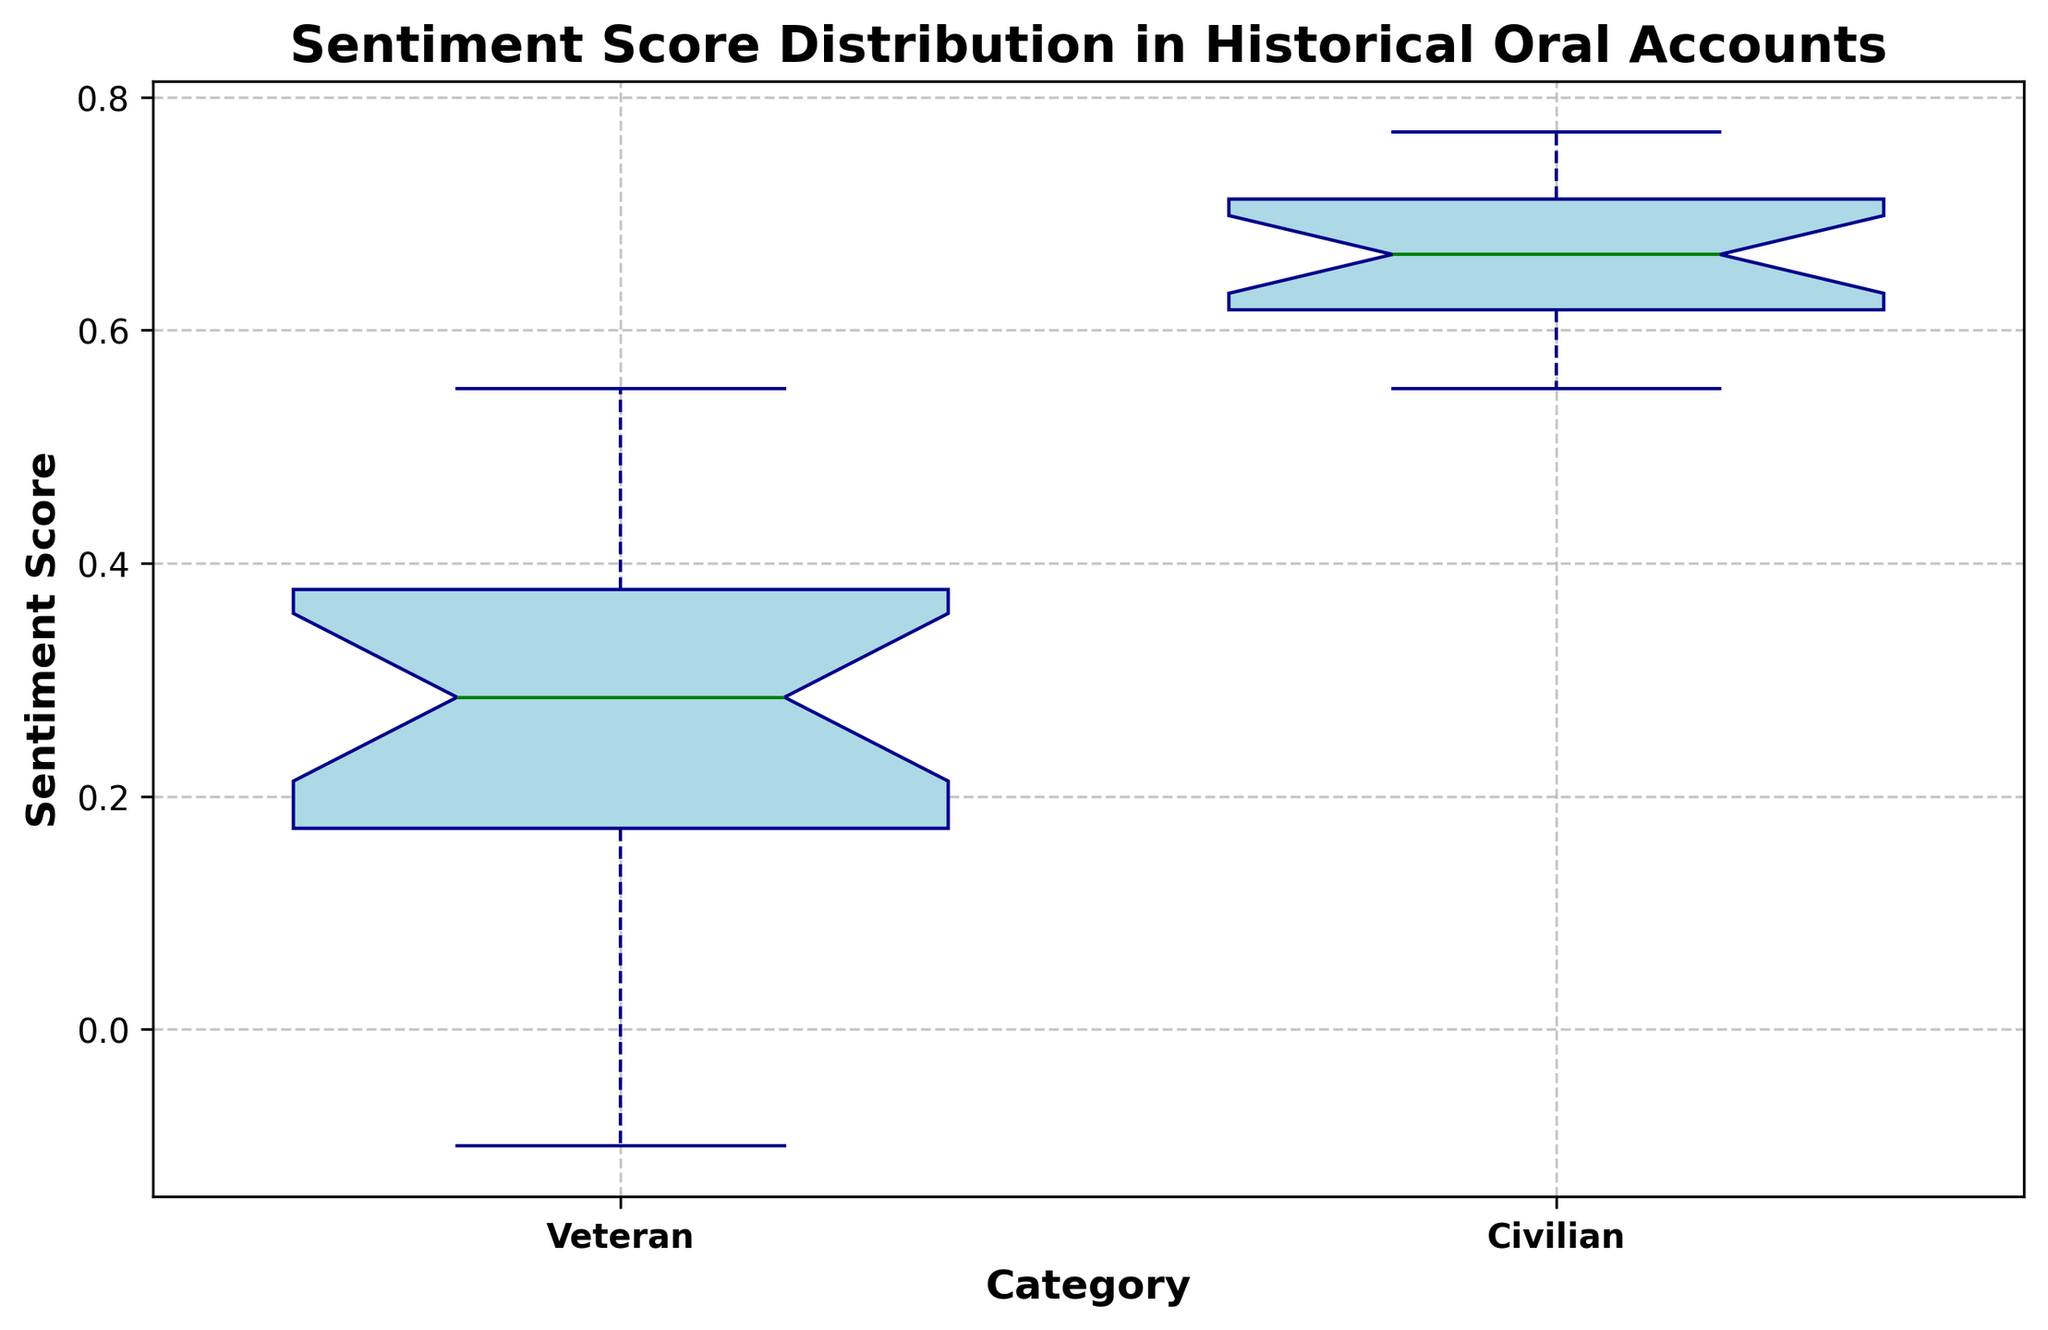What's the median sentiment score for veterans? To determine the median sentiment score for veterans, observe the central line within the veteran box in the box plot. The median is the value at which half the scores are above it and half below.
Answer: 0.25 Which group exhibits a greater range in sentiment scores? The range can be determined by the distance between the smallest and largest values (whiskers). For veterans, the whiskers span from -0.10 to 0.55, equaling 0.65. For civilians, the whiskers span from 0.55 to 0.77, equaling 0.22. Therefore, veterans exhibit a greater range.
Answer: Veterans What's the interquartile range (IQR) for civilian sentiment scores? The IQR is the difference between the upper quartile (Q3) and the lower quartile (Q1) in the box plot. For civilians, Q3 is around 0.70 and Q1 is around 0.62. Hence, IQR is 0.70 - 0.62 = 0.08.
Answer: 0.08 What is the difference in the median sentiment scores between civilians and veterans? Find the median sentiment scores for both groups from the central lines of their respective boxes. Civilians have a median around 0.67, and veterans around 0.25. The difference is 0.67 - 0.25 = 0.42.
Answer: 0.42 Which category displays more variability in sentiment scores? Variability can be assessed by the spread of the data within each box and whisker plot. Since veterans have a larger range (0.65) compared to civilians (0.22), the veterans display more variability.
Answer: Veterans Are there any outliers present? If so, in which group do they appear? Outliers are typically indicated by points outside the whiskers of the box plots. Here, there are no points or fliers visually identifiable outside the whiskers in either group.
Answer: No Which group shows the higher median sentiment score? The higher median sentiment score is indicated by the higher central line within the box. Comparing the boxes, civilians have a higher median score (around 0.67) than veterans (around 0.25).
Answer: Civilians What's the difference between the maximum sentiment score of veterans and civilians? The maximum scores are indicated by the top whiskers: veterans have a maximum around 0.55, civilians around 0.77. The difference is 0.77 - 0.55 = 0.22.
Answer: 0.22 